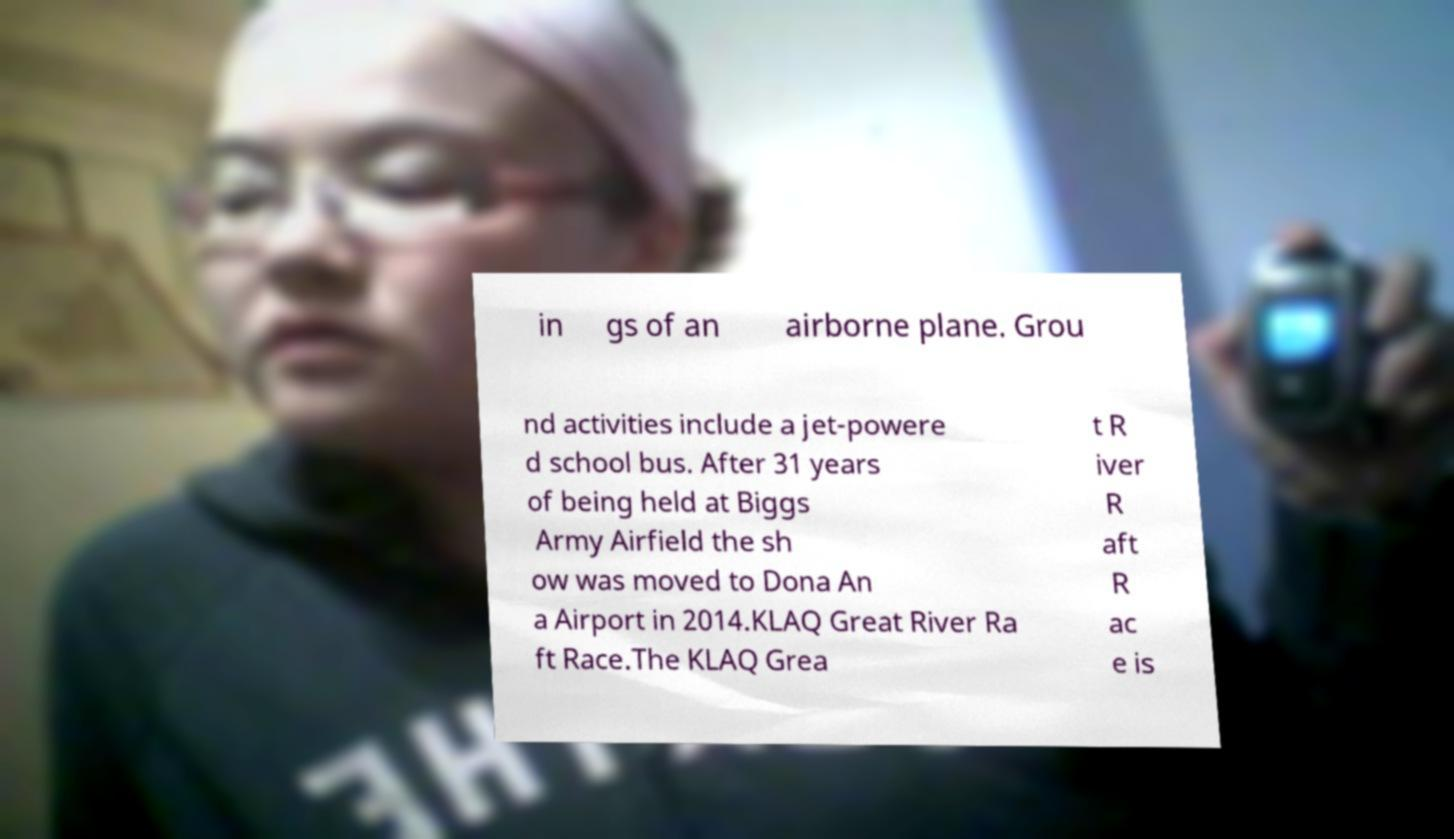Please read and relay the text visible in this image. What does it say? in gs of an airborne plane. Grou nd activities include a jet-powere d school bus. After 31 years of being held at Biggs Army Airfield the sh ow was moved to Dona An a Airport in 2014.KLAQ Great River Ra ft Race.The KLAQ Grea t R iver R aft R ac e is 